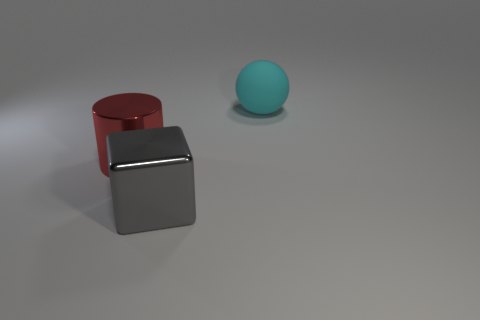Is the big thing that is left of the gray metal block made of the same material as the sphere to the right of the metal block?
Give a very brief answer. No. There is a big object left of the gray shiny thing; how many objects are right of it?
Provide a short and direct response. 2. Does the thing left of the big gray metal object have the same shape as the object that is behind the large cylinder?
Offer a very short reply. No. How big is the thing that is to the right of the big red metal cylinder and behind the big shiny cube?
Give a very brief answer. Large. What color is the cylinder that is to the left of the shiny thing in front of the red metal object?
Your answer should be very brief. Red. The red object is what shape?
Your answer should be compact. Cylinder. The big thing that is to the right of the large red metallic object and behind the large gray block has what shape?
Offer a terse response. Sphere. The other object that is made of the same material as the red object is what color?
Make the answer very short. Gray. What is the shape of the thing that is right of the large object in front of the large object that is to the left of the cube?
Your answer should be very brief. Sphere. The red metallic cylinder has what size?
Your answer should be very brief. Large. 